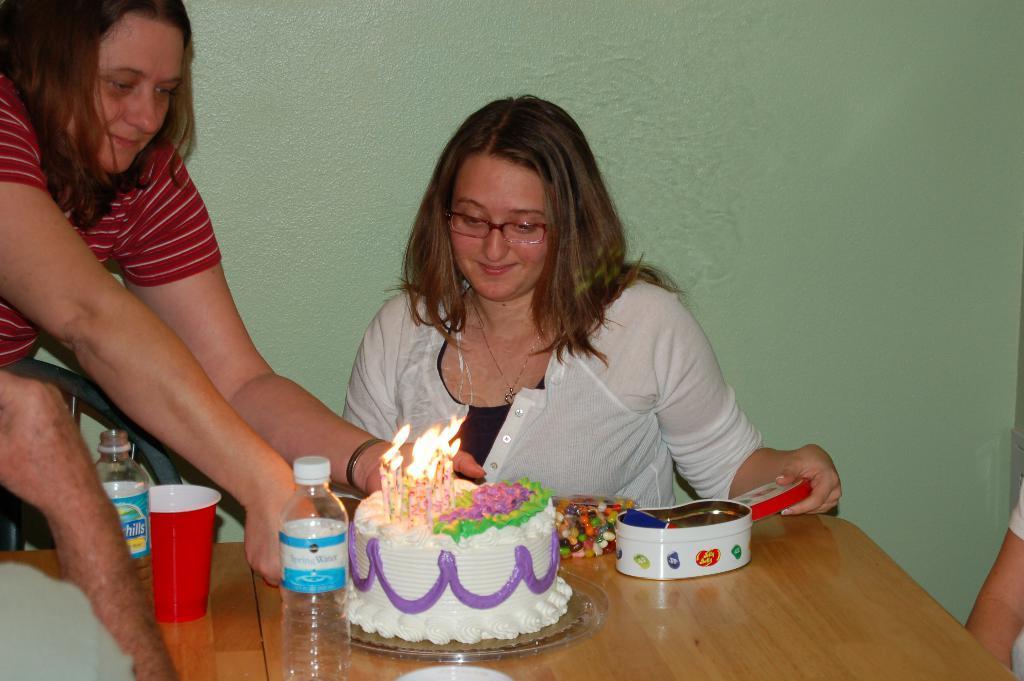How would you summarize this image in a sentence or two? In the picture we can see two women, one woman is standing and putting a cake on the table,another woman sitting near the table,on the table there was a cake,on the cake there was a candle light,on the table there was also water bottle,glass e. t. c. 